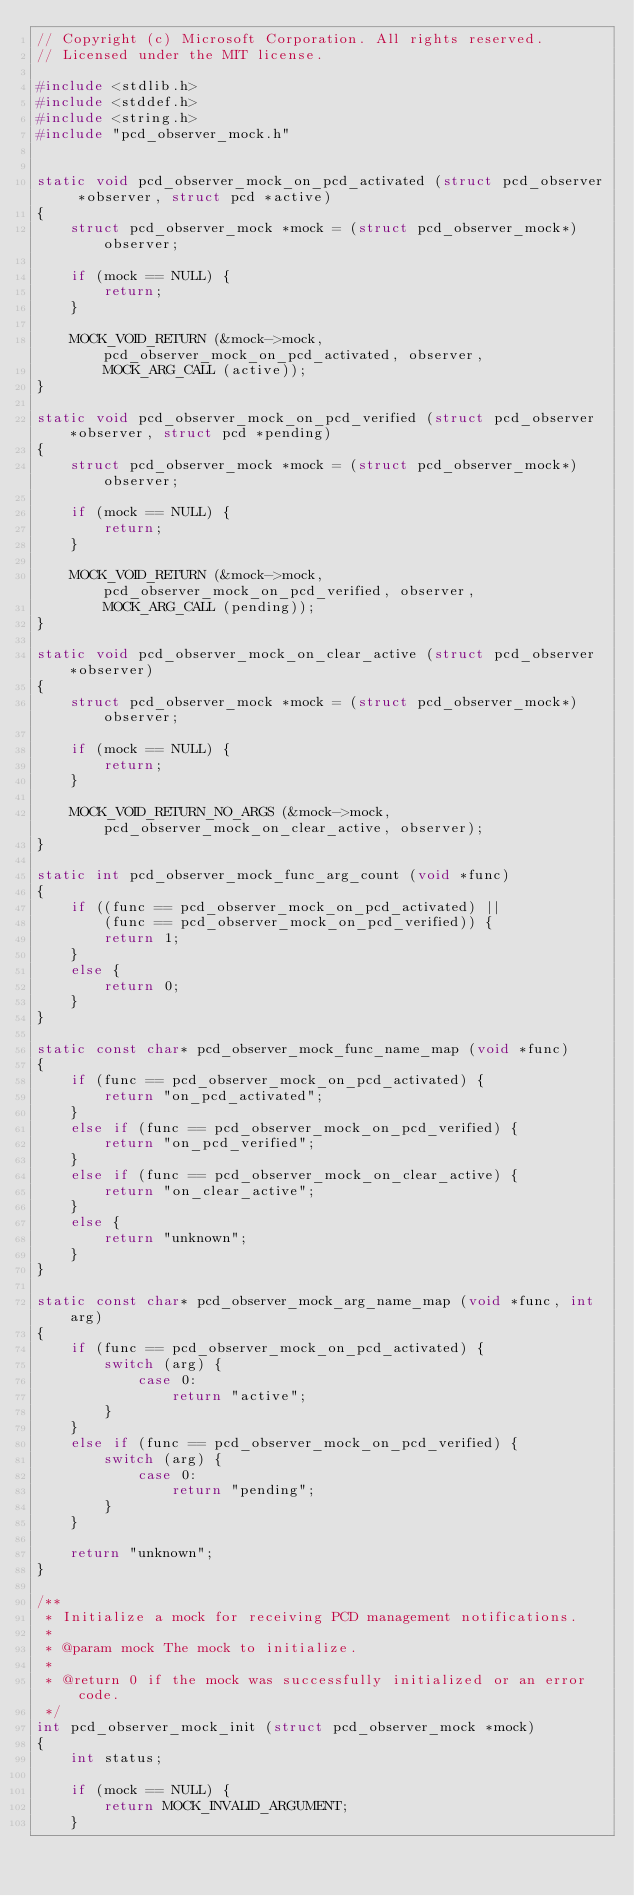<code> <loc_0><loc_0><loc_500><loc_500><_C_>// Copyright (c) Microsoft Corporation. All rights reserved.
// Licensed under the MIT license.

#include <stdlib.h>
#include <stddef.h>
#include <string.h>
#include "pcd_observer_mock.h"


static void pcd_observer_mock_on_pcd_activated (struct pcd_observer *observer, struct pcd *active)
{
	struct pcd_observer_mock *mock = (struct pcd_observer_mock*) observer;

	if (mock == NULL) {
		return;
	}

	MOCK_VOID_RETURN (&mock->mock, pcd_observer_mock_on_pcd_activated, observer,
		MOCK_ARG_CALL (active));
}

static void pcd_observer_mock_on_pcd_verified (struct pcd_observer *observer, struct pcd *pending)
{
	struct pcd_observer_mock *mock = (struct pcd_observer_mock*) observer;

	if (mock == NULL) {
		return;
	}

	MOCK_VOID_RETURN (&mock->mock, pcd_observer_mock_on_pcd_verified, observer,
		MOCK_ARG_CALL (pending));
}

static void pcd_observer_mock_on_clear_active (struct pcd_observer *observer)
{
	struct pcd_observer_mock *mock = (struct pcd_observer_mock*) observer;

	if (mock == NULL) {
		return;
	}

	MOCK_VOID_RETURN_NO_ARGS (&mock->mock, pcd_observer_mock_on_clear_active, observer);
}

static int pcd_observer_mock_func_arg_count (void *func)
{
	if ((func == pcd_observer_mock_on_pcd_activated) ||
		(func == pcd_observer_mock_on_pcd_verified)) {
		return 1;
	}
	else {
		return 0;
	}
}

static const char* pcd_observer_mock_func_name_map (void *func)
{
	if (func == pcd_observer_mock_on_pcd_activated) {
		return "on_pcd_activated";
	}
	else if (func == pcd_observer_mock_on_pcd_verified) {
		return "on_pcd_verified";
	}
	else if (func == pcd_observer_mock_on_clear_active) {
		return "on_clear_active";
	}
	else {
		return "unknown";
	}
}

static const char* pcd_observer_mock_arg_name_map (void *func, int arg)
{
	if (func == pcd_observer_mock_on_pcd_activated) {
		switch (arg) {
			case 0:
				return "active";
		}
	}
	else if (func == pcd_observer_mock_on_pcd_verified) {
		switch (arg) {
			case 0:
				return "pending";
		}
	}

	return "unknown";
}

/**
 * Initialize a mock for receiving PCD management notifications.
 *
 * @param mock The mock to initialize.
 *
 * @return 0 if the mock was successfully initialized or an error code.
 */
int pcd_observer_mock_init (struct pcd_observer_mock *mock)
{
	int status;

	if (mock == NULL) {
		return MOCK_INVALID_ARGUMENT;
	}
</code> 